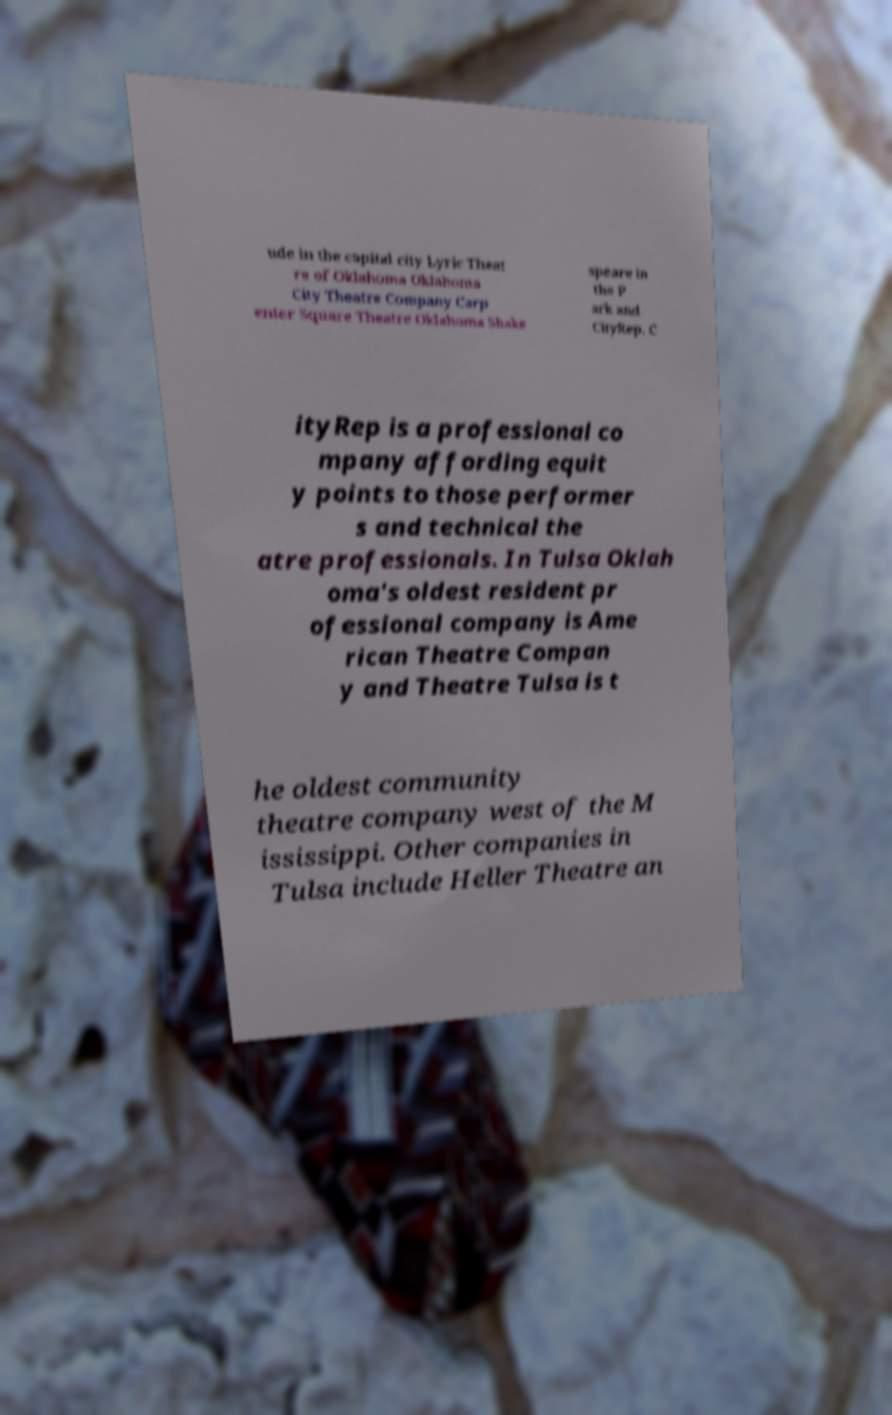Could you assist in decoding the text presented in this image and type it out clearly? ude in the capital city Lyric Theat re of Oklahoma Oklahoma City Theatre Company Carp enter Square Theatre Oklahoma Shake speare in the P ark and CityRep. C ityRep is a professional co mpany affording equit y points to those performer s and technical the atre professionals. In Tulsa Oklah oma's oldest resident pr ofessional company is Ame rican Theatre Compan y and Theatre Tulsa is t he oldest community theatre company west of the M ississippi. Other companies in Tulsa include Heller Theatre an 